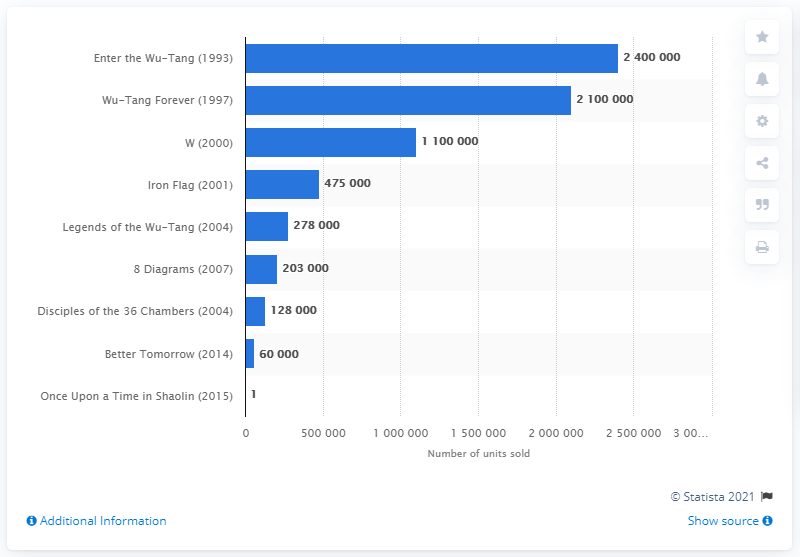Highlight a few significant elements in this photo. According to sales data in the United States, the album "Wu-Tang Forever" sold approximately 210,000 copies. The greatest disparity between the best-selling album and the least well-performing album on the chart is 2399999.. The total number of units sold of the 8 Diagrams album is approximately 203,000. 